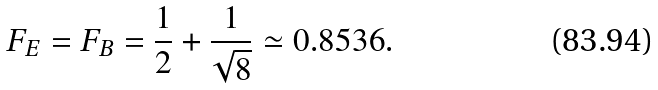Convert formula to latex. <formula><loc_0><loc_0><loc_500><loc_500>F _ { E } = F _ { B } = \frac { 1 } { 2 } + \frac { 1 } { \sqrt { 8 } } \simeq 0 . 8 5 3 6 .</formula> 